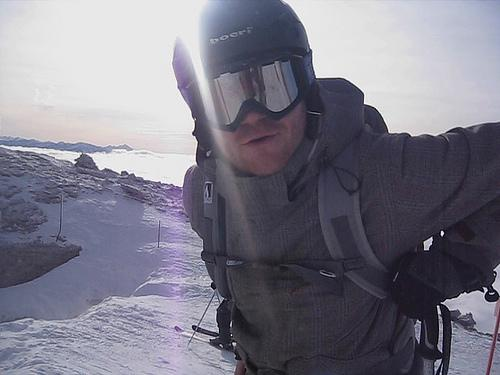What nationality were the founders of this helmet company?

Choices:
A) italian
B) swiss
C) french
D) russian italian 